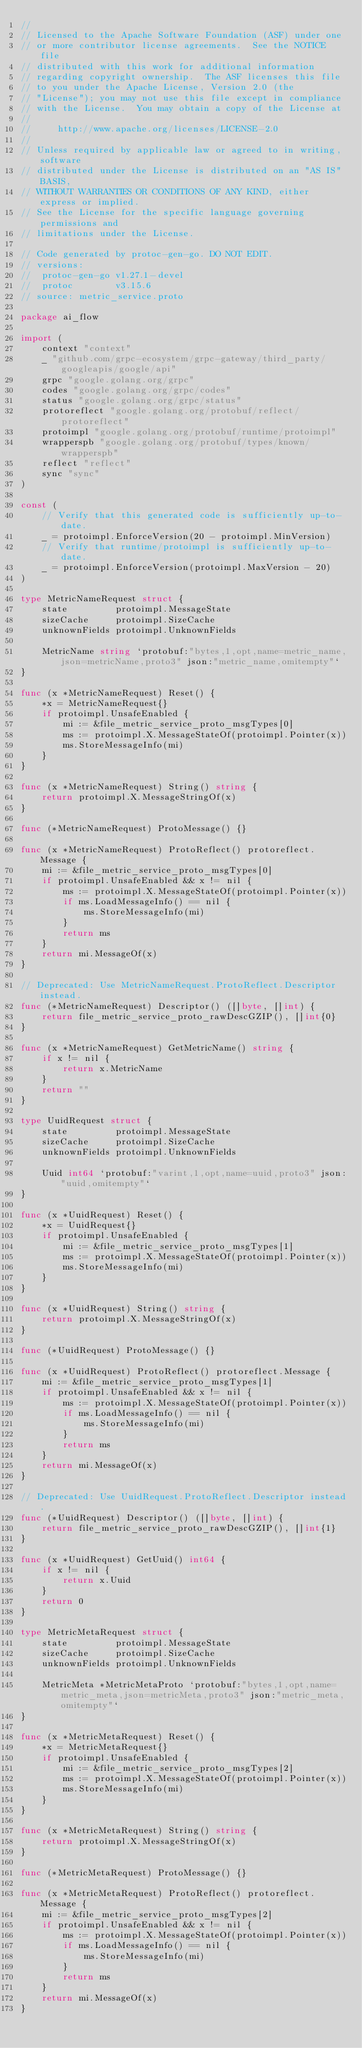Convert code to text. <code><loc_0><loc_0><loc_500><loc_500><_Go_>//
// Licensed to the Apache Software Foundation (ASF) under one
// or more contributor license agreements.  See the NOTICE file
// distributed with this work for additional information
// regarding copyright ownership.  The ASF licenses this file
// to you under the Apache License, Version 2.0 (the
// "License"); you may not use this file except in compliance
// with the License.  You may obtain a copy of the License at
//
//     http://www.apache.org/licenses/LICENSE-2.0
//
// Unless required by applicable law or agreed to in writing, software
// distributed under the License is distributed on an "AS IS" BASIS,
// WITHOUT WARRANTIES OR CONDITIONS OF ANY KIND, either express or implied.
// See the License for the specific language governing permissions and
// limitations under the License.

// Code generated by protoc-gen-go. DO NOT EDIT.
// versions:
// 	protoc-gen-go v1.27.1-devel
// 	protoc        v3.15.6
// source: metric_service.proto

package ai_flow

import (
	context "context"
	_ "github.com/grpc-ecosystem/grpc-gateway/third_party/googleapis/google/api"
	grpc "google.golang.org/grpc"
	codes "google.golang.org/grpc/codes"
	status "google.golang.org/grpc/status"
	protoreflect "google.golang.org/protobuf/reflect/protoreflect"
	protoimpl "google.golang.org/protobuf/runtime/protoimpl"
	wrapperspb "google.golang.org/protobuf/types/known/wrapperspb"
	reflect "reflect"
	sync "sync"
)

const (
	// Verify that this generated code is sufficiently up-to-date.
	_ = protoimpl.EnforceVersion(20 - protoimpl.MinVersion)
	// Verify that runtime/protoimpl is sufficiently up-to-date.
	_ = protoimpl.EnforceVersion(protoimpl.MaxVersion - 20)
)

type MetricNameRequest struct {
	state         protoimpl.MessageState
	sizeCache     protoimpl.SizeCache
	unknownFields protoimpl.UnknownFields

	MetricName string `protobuf:"bytes,1,opt,name=metric_name,json=metricName,proto3" json:"metric_name,omitempty"`
}

func (x *MetricNameRequest) Reset() {
	*x = MetricNameRequest{}
	if protoimpl.UnsafeEnabled {
		mi := &file_metric_service_proto_msgTypes[0]
		ms := protoimpl.X.MessageStateOf(protoimpl.Pointer(x))
		ms.StoreMessageInfo(mi)
	}
}

func (x *MetricNameRequest) String() string {
	return protoimpl.X.MessageStringOf(x)
}

func (*MetricNameRequest) ProtoMessage() {}

func (x *MetricNameRequest) ProtoReflect() protoreflect.Message {
	mi := &file_metric_service_proto_msgTypes[0]
	if protoimpl.UnsafeEnabled && x != nil {
		ms := protoimpl.X.MessageStateOf(protoimpl.Pointer(x))
		if ms.LoadMessageInfo() == nil {
			ms.StoreMessageInfo(mi)
		}
		return ms
	}
	return mi.MessageOf(x)
}

// Deprecated: Use MetricNameRequest.ProtoReflect.Descriptor instead.
func (*MetricNameRequest) Descriptor() ([]byte, []int) {
	return file_metric_service_proto_rawDescGZIP(), []int{0}
}

func (x *MetricNameRequest) GetMetricName() string {
	if x != nil {
		return x.MetricName
	}
	return ""
}

type UuidRequest struct {
	state         protoimpl.MessageState
	sizeCache     protoimpl.SizeCache
	unknownFields protoimpl.UnknownFields

	Uuid int64 `protobuf:"varint,1,opt,name=uuid,proto3" json:"uuid,omitempty"`
}

func (x *UuidRequest) Reset() {
	*x = UuidRequest{}
	if protoimpl.UnsafeEnabled {
		mi := &file_metric_service_proto_msgTypes[1]
		ms := protoimpl.X.MessageStateOf(protoimpl.Pointer(x))
		ms.StoreMessageInfo(mi)
	}
}

func (x *UuidRequest) String() string {
	return protoimpl.X.MessageStringOf(x)
}

func (*UuidRequest) ProtoMessage() {}

func (x *UuidRequest) ProtoReflect() protoreflect.Message {
	mi := &file_metric_service_proto_msgTypes[1]
	if protoimpl.UnsafeEnabled && x != nil {
		ms := protoimpl.X.MessageStateOf(protoimpl.Pointer(x))
		if ms.LoadMessageInfo() == nil {
			ms.StoreMessageInfo(mi)
		}
		return ms
	}
	return mi.MessageOf(x)
}

// Deprecated: Use UuidRequest.ProtoReflect.Descriptor instead.
func (*UuidRequest) Descriptor() ([]byte, []int) {
	return file_metric_service_proto_rawDescGZIP(), []int{1}
}

func (x *UuidRequest) GetUuid() int64 {
	if x != nil {
		return x.Uuid
	}
	return 0
}

type MetricMetaRequest struct {
	state         protoimpl.MessageState
	sizeCache     protoimpl.SizeCache
	unknownFields protoimpl.UnknownFields

	MetricMeta *MetricMetaProto `protobuf:"bytes,1,opt,name=metric_meta,json=metricMeta,proto3" json:"metric_meta,omitempty"`
}

func (x *MetricMetaRequest) Reset() {
	*x = MetricMetaRequest{}
	if protoimpl.UnsafeEnabled {
		mi := &file_metric_service_proto_msgTypes[2]
		ms := protoimpl.X.MessageStateOf(protoimpl.Pointer(x))
		ms.StoreMessageInfo(mi)
	}
}

func (x *MetricMetaRequest) String() string {
	return protoimpl.X.MessageStringOf(x)
}

func (*MetricMetaRequest) ProtoMessage() {}

func (x *MetricMetaRequest) ProtoReflect() protoreflect.Message {
	mi := &file_metric_service_proto_msgTypes[2]
	if protoimpl.UnsafeEnabled && x != nil {
		ms := protoimpl.X.MessageStateOf(protoimpl.Pointer(x))
		if ms.LoadMessageInfo() == nil {
			ms.StoreMessageInfo(mi)
		}
		return ms
	}
	return mi.MessageOf(x)
}
</code> 